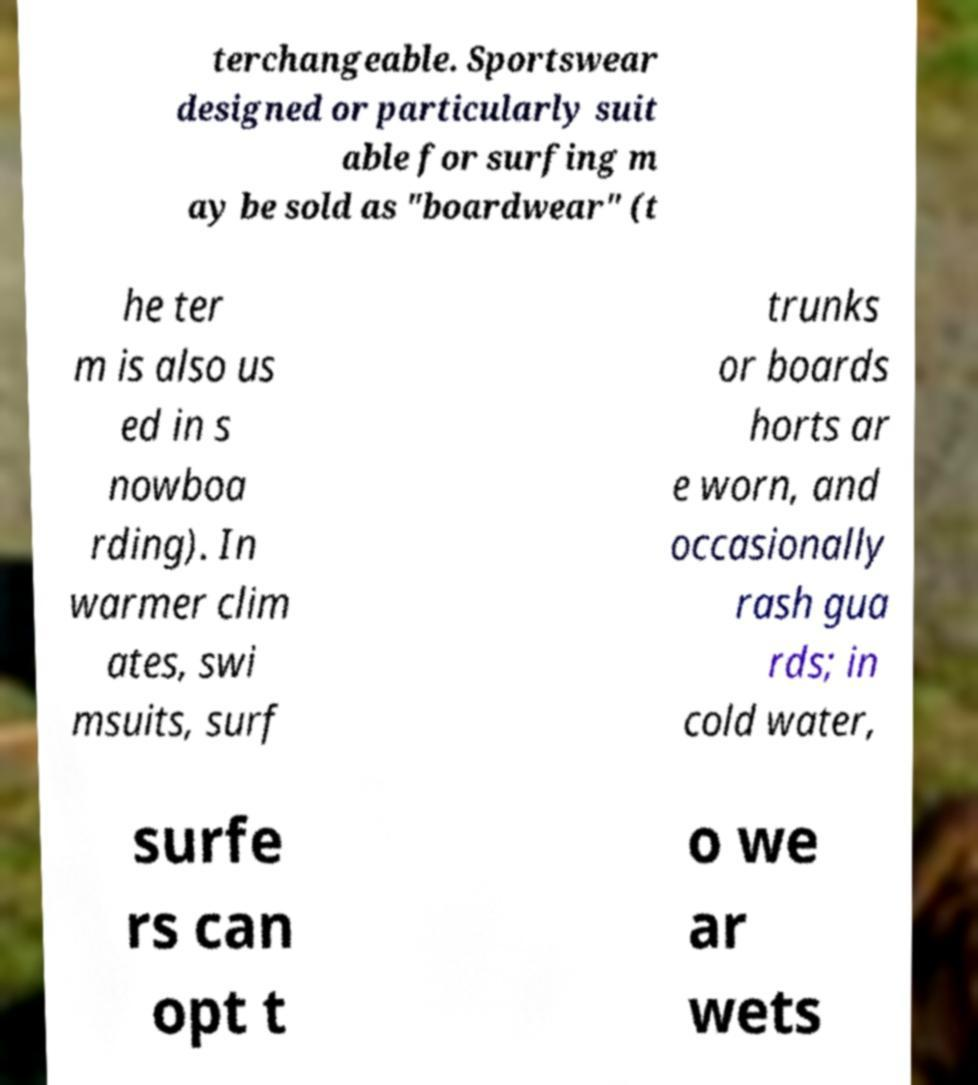Can you accurately transcribe the text from the provided image for me? terchangeable. Sportswear designed or particularly suit able for surfing m ay be sold as "boardwear" (t he ter m is also us ed in s nowboa rding). In warmer clim ates, swi msuits, surf trunks or boards horts ar e worn, and occasionally rash gua rds; in cold water, surfe rs can opt t o we ar wets 